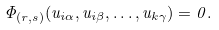<formula> <loc_0><loc_0><loc_500><loc_500>\Phi _ { ( r , s ) } ( u _ { i \alpha } , u _ { i \beta } , \dots , u _ { k \gamma } ) = 0 .</formula> 